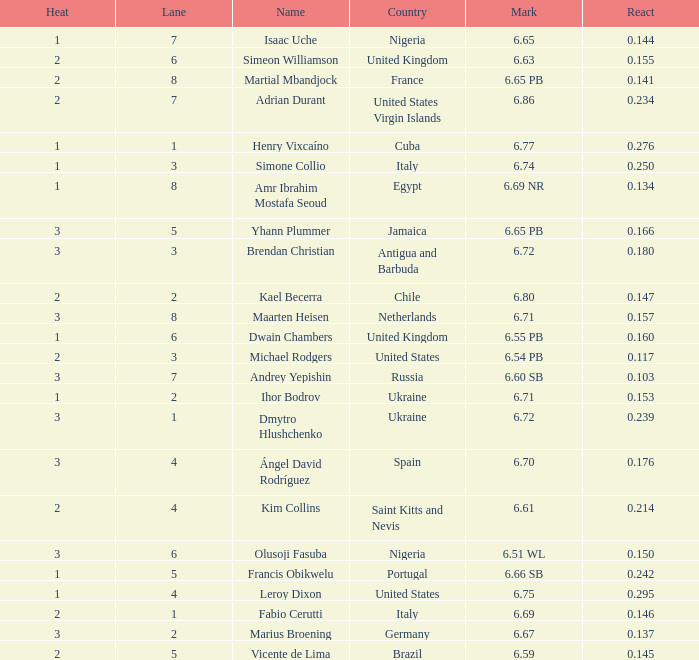What is Mark, when Name is Dmytro Hlushchenko? 6.72. 